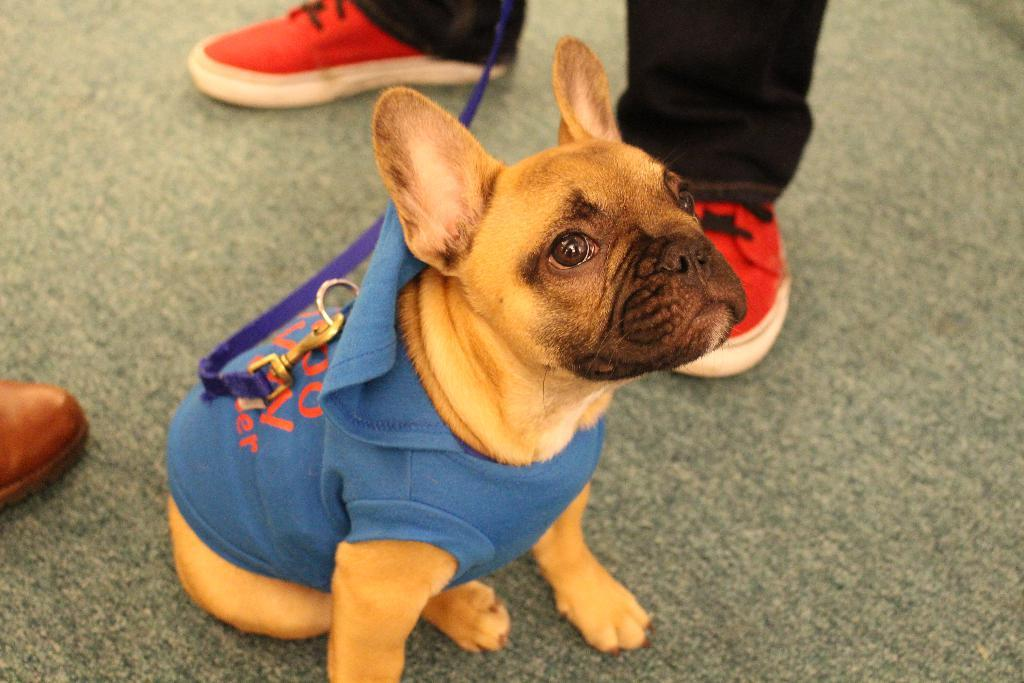What type of animal is in the image? There is a dog in the image. How is the dog dressed in the image? The dog is wearing a belt and a dress. Can you describe any human elements in the image? There are legs of persons visible in the image. What can be seen on the left side of the image? On the left side of the image, there is a part of a shoe. Where is the island located in the image? There is no island present in the image. How old is the baby in the image? There is no baby present in the image. 